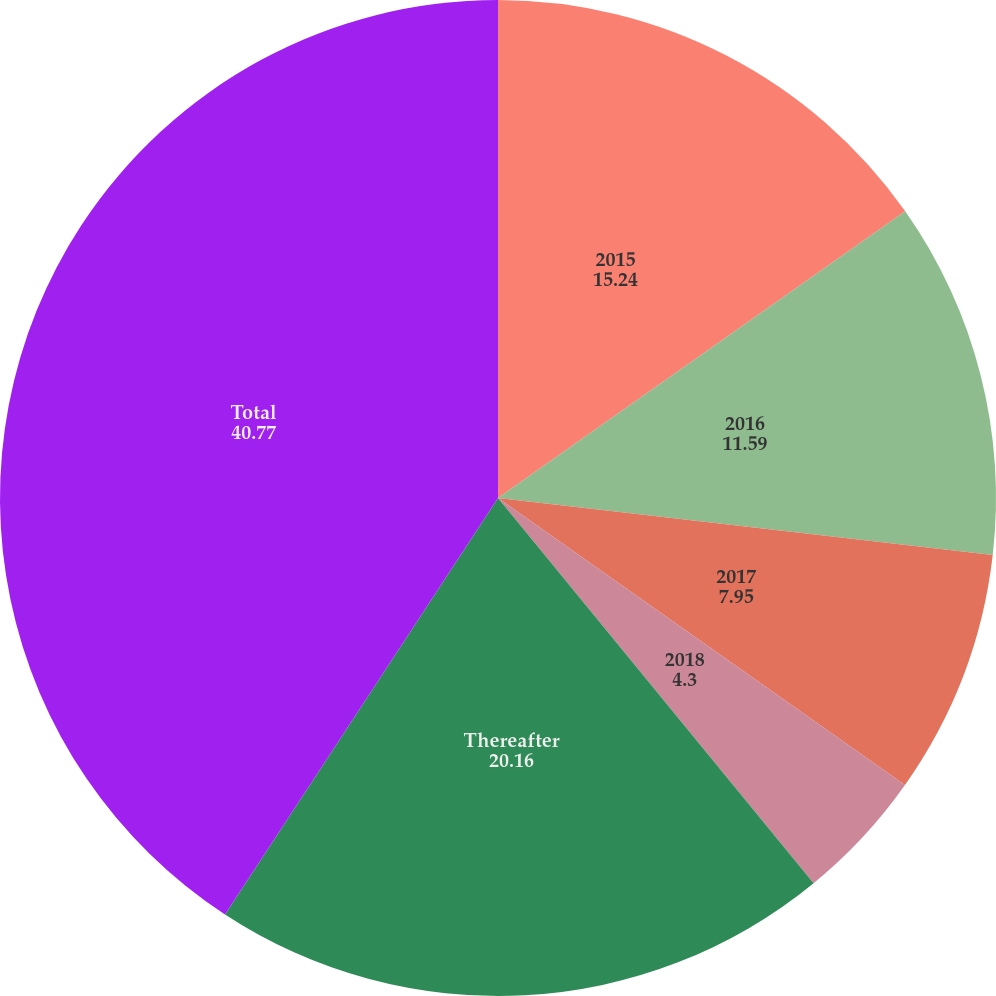<chart> <loc_0><loc_0><loc_500><loc_500><pie_chart><fcel>2015<fcel>2016<fcel>2017<fcel>2018<fcel>Thereafter<fcel>Total<nl><fcel>15.24%<fcel>11.59%<fcel>7.95%<fcel>4.3%<fcel>20.16%<fcel>40.77%<nl></chart> 